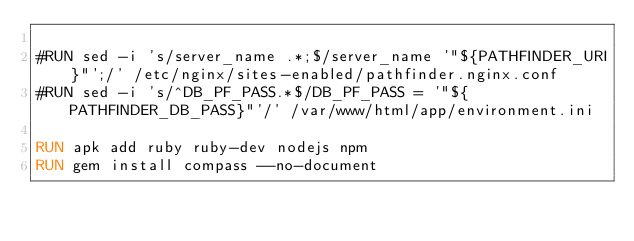<code> <loc_0><loc_0><loc_500><loc_500><_Dockerfile_>
#RUN sed -i 's/server_name .*;$/server_name '"${PATHFINDER_URI}"';/' /etc/nginx/sites-enabled/pathfinder.nginx.conf
#RUN sed -i 's/^DB_PF_PASS.*$/DB_PF_PASS = '"${PATHFINDER_DB_PASS}"'/' /var/www/html/app/environment.ini

RUN apk add ruby ruby-dev nodejs npm
RUN gem install compass --no-document
</code> 